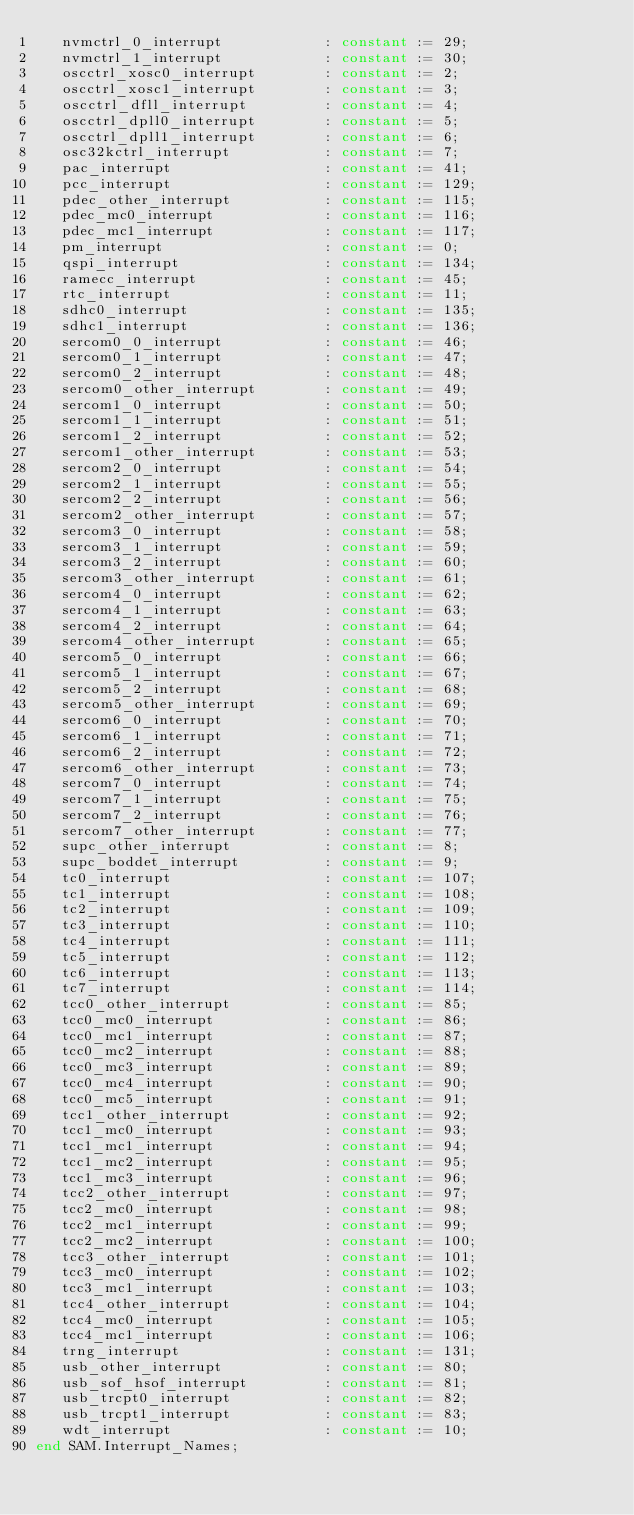Convert code to text. <code><loc_0><loc_0><loc_500><loc_500><_Ada_>   nvmctrl_0_interrupt            : constant := 29;
   nvmctrl_1_interrupt            : constant := 30;
   oscctrl_xosc0_interrupt        : constant := 2;
   oscctrl_xosc1_interrupt        : constant := 3;
   oscctrl_dfll_interrupt         : constant := 4;
   oscctrl_dpll0_interrupt        : constant := 5;
   oscctrl_dpll1_interrupt        : constant := 6;
   osc32kctrl_interrupt           : constant := 7;
   pac_interrupt                  : constant := 41;
   pcc_interrupt                  : constant := 129;
   pdec_other_interrupt           : constant := 115;
   pdec_mc0_interrupt             : constant := 116;
   pdec_mc1_interrupt             : constant := 117;
   pm_interrupt                   : constant := 0;
   qspi_interrupt                 : constant := 134;
   ramecc_interrupt               : constant := 45;
   rtc_interrupt                  : constant := 11;
   sdhc0_interrupt                : constant := 135;
   sdhc1_interrupt                : constant := 136;
   sercom0_0_interrupt            : constant := 46;
   sercom0_1_interrupt            : constant := 47;
   sercom0_2_interrupt            : constant := 48;
   sercom0_other_interrupt        : constant := 49;
   sercom1_0_interrupt            : constant := 50;
   sercom1_1_interrupt            : constant := 51;
   sercom1_2_interrupt            : constant := 52;
   sercom1_other_interrupt        : constant := 53;
   sercom2_0_interrupt            : constant := 54;
   sercom2_1_interrupt            : constant := 55;
   sercom2_2_interrupt            : constant := 56;
   sercom2_other_interrupt        : constant := 57;
   sercom3_0_interrupt            : constant := 58;
   sercom3_1_interrupt            : constant := 59;
   sercom3_2_interrupt            : constant := 60;
   sercom3_other_interrupt        : constant := 61;
   sercom4_0_interrupt            : constant := 62;
   sercom4_1_interrupt            : constant := 63;
   sercom4_2_interrupt            : constant := 64;
   sercom4_other_interrupt        : constant := 65;
   sercom5_0_interrupt            : constant := 66;
   sercom5_1_interrupt            : constant := 67;
   sercom5_2_interrupt            : constant := 68;
   sercom5_other_interrupt        : constant := 69;
   sercom6_0_interrupt            : constant := 70;
   sercom6_1_interrupt            : constant := 71;
   sercom6_2_interrupt            : constant := 72;
   sercom6_other_interrupt        : constant := 73;
   sercom7_0_interrupt            : constant := 74;
   sercom7_1_interrupt            : constant := 75;
   sercom7_2_interrupt            : constant := 76;
   sercom7_other_interrupt        : constant := 77;
   supc_other_interrupt           : constant := 8;
   supc_boddet_interrupt          : constant := 9;
   tc0_interrupt                  : constant := 107;
   tc1_interrupt                  : constant := 108;
   tc2_interrupt                  : constant := 109;
   tc3_interrupt                  : constant := 110;
   tc4_interrupt                  : constant := 111;
   tc5_interrupt                  : constant := 112;
   tc6_interrupt                  : constant := 113;
   tc7_interrupt                  : constant := 114;
   tcc0_other_interrupt           : constant := 85;
   tcc0_mc0_interrupt             : constant := 86;
   tcc0_mc1_interrupt             : constant := 87;
   tcc0_mc2_interrupt             : constant := 88;
   tcc0_mc3_interrupt             : constant := 89;
   tcc0_mc4_interrupt             : constant := 90;
   tcc0_mc5_interrupt             : constant := 91;
   tcc1_other_interrupt           : constant := 92;
   tcc1_mc0_interrupt             : constant := 93;
   tcc1_mc1_interrupt             : constant := 94;
   tcc1_mc2_interrupt             : constant := 95;
   tcc1_mc3_interrupt             : constant := 96;
   tcc2_other_interrupt           : constant := 97;
   tcc2_mc0_interrupt             : constant := 98;
   tcc2_mc1_interrupt             : constant := 99;
   tcc2_mc2_interrupt             : constant := 100;
   tcc3_other_interrupt           : constant := 101;
   tcc3_mc0_interrupt             : constant := 102;
   tcc3_mc1_interrupt             : constant := 103;
   tcc4_other_interrupt           : constant := 104;
   tcc4_mc0_interrupt             : constant := 105;
   tcc4_mc1_interrupt             : constant := 106;
   trng_interrupt                 : constant := 131;
   usb_other_interrupt            : constant := 80;
   usb_sof_hsof_interrupt         : constant := 81;
   usb_trcpt0_interrupt           : constant := 82;
   usb_trcpt1_interrupt           : constant := 83;
   wdt_interrupt                  : constant := 10;
end SAM.Interrupt_Names;
</code> 